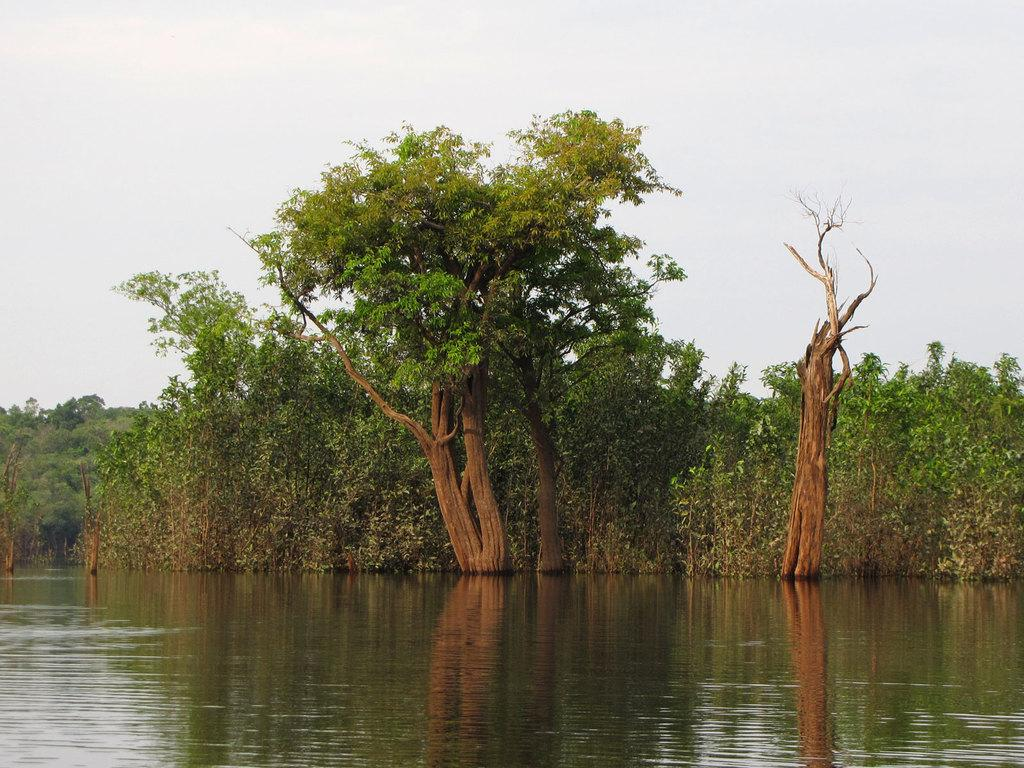What is in the front of the image? There is water in the front of the image. What can be seen in the background of the image? There are trees and the sky visible in the background of the image. Where is the playground located in the image? There is no playground present in the image. What type of sugar can be seen growing on the trees in the image? There are no sugar-producing plants or trees visible in the image. 